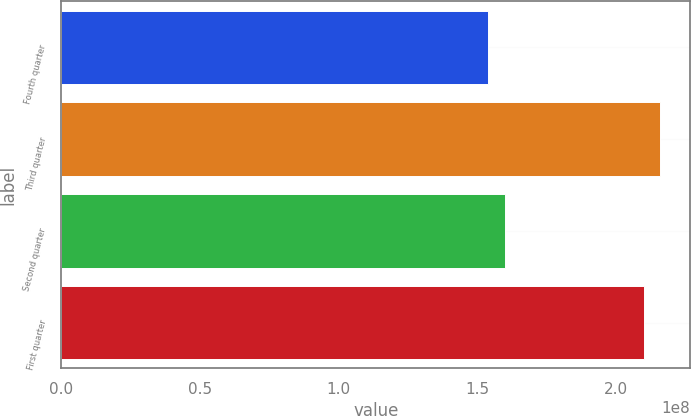Convert chart to OTSL. <chart><loc_0><loc_0><loc_500><loc_500><bar_chart><fcel>Fourth quarter<fcel>Third quarter<fcel>Second quarter<fcel>First quarter<nl><fcel>1.53989e+08<fcel>2.15973e+08<fcel>1.59893e+08<fcel>2.10069e+08<nl></chart> 